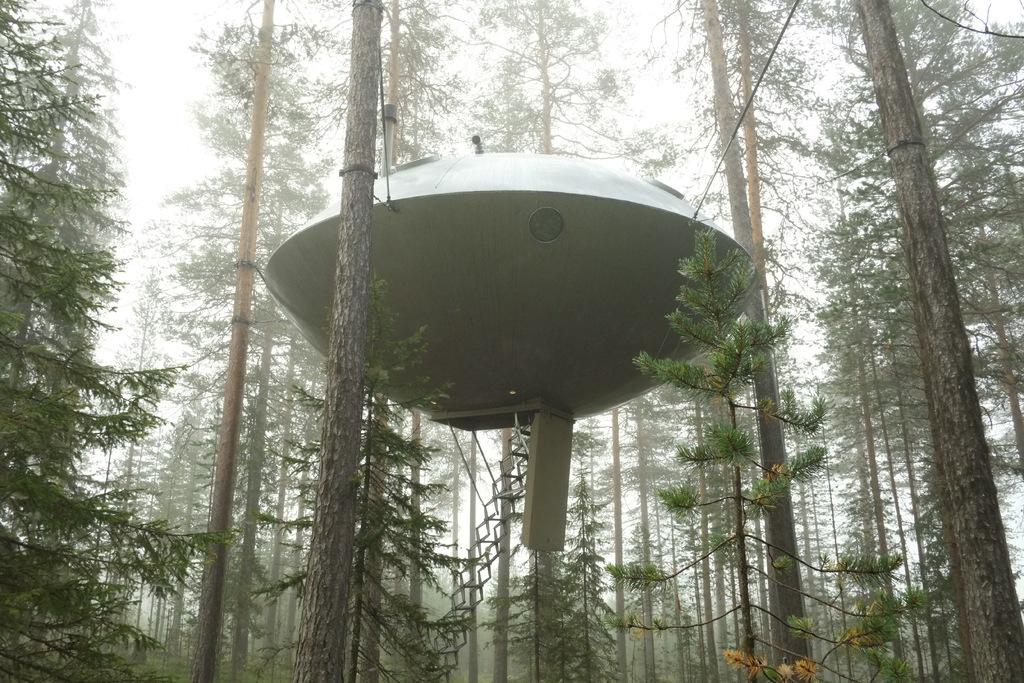What is the shape of the main object in the image? The main object in the image is in the shape of an oval. What feature does the oval object have? The oval object has stairs. What type of natural elements can be seen in the image? There are trees in the image. What color is the crayon in the middle of the image? There is no crayon present in the image. What type of cloth is draped over the oval object in the image? There is no cloth draped over the oval object in the image. 